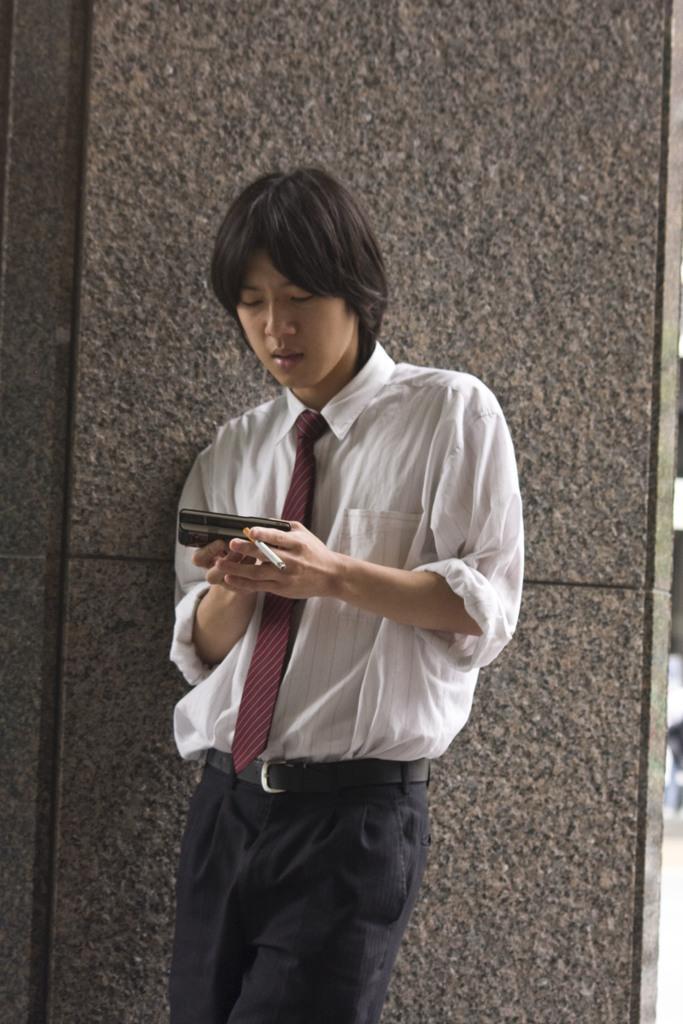Please provide a concise description of this image. There is one man standing and holding a mobile and a cigarette in the middle of this image. We can see a wall in the background. 